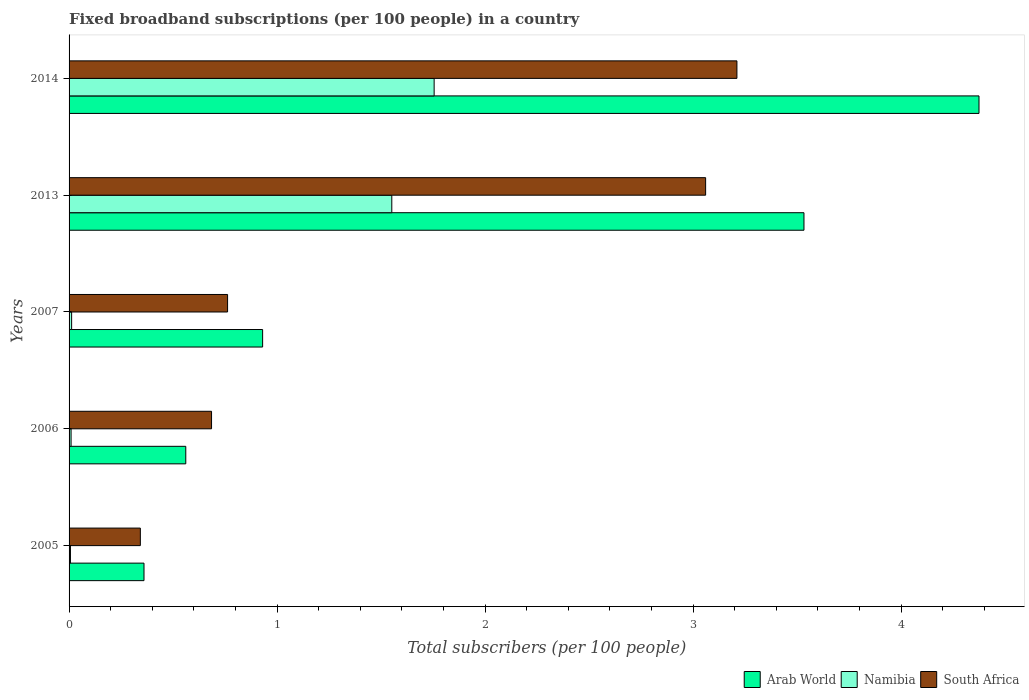How many groups of bars are there?
Offer a terse response. 5. How many bars are there on the 5th tick from the top?
Keep it short and to the point. 3. What is the number of broadband subscriptions in South Africa in 2005?
Your response must be concise. 0.34. Across all years, what is the maximum number of broadband subscriptions in Arab World?
Keep it short and to the point. 4.37. Across all years, what is the minimum number of broadband subscriptions in South Africa?
Offer a terse response. 0.34. In which year was the number of broadband subscriptions in Namibia maximum?
Provide a succinct answer. 2014. In which year was the number of broadband subscriptions in Arab World minimum?
Make the answer very short. 2005. What is the total number of broadband subscriptions in Namibia in the graph?
Offer a very short reply. 3.34. What is the difference between the number of broadband subscriptions in Namibia in 2005 and that in 2007?
Give a very brief answer. -0.01. What is the difference between the number of broadband subscriptions in Namibia in 2006 and the number of broadband subscriptions in South Africa in 2013?
Provide a succinct answer. -3.05. What is the average number of broadband subscriptions in South Africa per year?
Your answer should be compact. 1.61. In the year 2005, what is the difference between the number of broadband subscriptions in Namibia and number of broadband subscriptions in South Africa?
Keep it short and to the point. -0.34. What is the ratio of the number of broadband subscriptions in South Africa in 2013 to that in 2014?
Keep it short and to the point. 0.95. What is the difference between the highest and the second highest number of broadband subscriptions in South Africa?
Offer a terse response. 0.15. What is the difference between the highest and the lowest number of broadband subscriptions in Arab World?
Provide a short and direct response. 4.01. In how many years, is the number of broadband subscriptions in Namibia greater than the average number of broadband subscriptions in Namibia taken over all years?
Offer a very short reply. 2. What does the 3rd bar from the top in 2006 represents?
Your response must be concise. Arab World. What does the 1st bar from the bottom in 2006 represents?
Keep it short and to the point. Arab World. Is it the case that in every year, the sum of the number of broadband subscriptions in Arab World and number of broadband subscriptions in South Africa is greater than the number of broadband subscriptions in Namibia?
Provide a succinct answer. Yes. How many bars are there?
Keep it short and to the point. 15. Are all the bars in the graph horizontal?
Your answer should be compact. Yes. How many years are there in the graph?
Offer a very short reply. 5. Are the values on the major ticks of X-axis written in scientific E-notation?
Your answer should be very brief. No. Does the graph contain any zero values?
Make the answer very short. No. Does the graph contain grids?
Give a very brief answer. No. Where does the legend appear in the graph?
Your answer should be compact. Bottom right. How are the legend labels stacked?
Your answer should be compact. Horizontal. What is the title of the graph?
Your answer should be compact. Fixed broadband subscriptions (per 100 people) in a country. What is the label or title of the X-axis?
Your answer should be very brief. Total subscribers (per 100 people). What is the Total subscribers (per 100 people) in Arab World in 2005?
Offer a very short reply. 0.36. What is the Total subscribers (per 100 people) of Namibia in 2005?
Offer a very short reply. 0.01. What is the Total subscribers (per 100 people) in South Africa in 2005?
Keep it short and to the point. 0.34. What is the Total subscribers (per 100 people) in Arab World in 2006?
Provide a short and direct response. 0.56. What is the Total subscribers (per 100 people) in Namibia in 2006?
Offer a very short reply. 0.01. What is the Total subscribers (per 100 people) in South Africa in 2006?
Keep it short and to the point. 0.69. What is the Total subscribers (per 100 people) in Arab World in 2007?
Your response must be concise. 0.93. What is the Total subscribers (per 100 people) in Namibia in 2007?
Your response must be concise. 0.01. What is the Total subscribers (per 100 people) in South Africa in 2007?
Provide a short and direct response. 0.76. What is the Total subscribers (per 100 people) of Arab World in 2013?
Give a very brief answer. 3.53. What is the Total subscribers (per 100 people) of Namibia in 2013?
Offer a very short reply. 1.55. What is the Total subscribers (per 100 people) of South Africa in 2013?
Ensure brevity in your answer.  3.06. What is the Total subscribers (per 100 people) of Arab World in 2014?
Your answer should be very brief. 4.37. What is the Total subscribers (per 100 people) of Namibia in 2014?
Your answer should be compact. 1.76. What is the Total subscribers (per 100 people) in South Africa in 2014?
Give a very brief answer. 3.21. Across all years, what is the maximum Total subscribers (per 100 people) of Arab World?
Provide a short and direct response. 4.37. Across all years, what is the maximum Total subscribers (per 100 people) of Namibia?
Your answer should be very brief. 1.76. Across all years, what is the maximum Total subscribers (per 100 people) in South Africa?
Provide a succinct answer. 3.21. Across all years, what is the minimum Total subscribers (per 100 people) of Arab World?
Offer a terse response. 0.36. Across all years, what is the minimum Total subscribers (per 100 people) of Namibia?
Provide a succinct answer. 0.01. Across all years, what is the minimum Total subscribers (per 100 people) of South Africa?
Offer a very short reply. 0.34. What is the total Total subscribers (per 100 people) in Arab World in the graph?
Offer a very short reply. 9.76. What is the total Total subscribers (per 100 people) in Namibia in the graph?
Provide a short and direct response. 3.34. What is the total Total subscribers (per 100 people) of South Africa in the graph?
Ensure brevity in your answer.  8.06. What is the difference between the Total subscribers (per 100 people) of Arab World in 2005 and that in 2006?
Make the answer very short. -0.2. What is the difference between the Total subscribers (per 100 people) of Namibia in 2005 and that in 2006?
Ensure brevity in your answer.  -0. What is the difference between the Total subscribers (per 100 people) of South Africa in 2005 and that in 2006?
Provide a succinct answer. -0.34. What is the difference between the Total subscribers (per 100 people) in Arab World in 2005 and that in 2007?
Your response must be concise. -0.57. What is the difference between the Total subscribers (per 100 people) in Namibia in 2005 and that in 2007?
Your answer should be compact. -0.01. What is the difference between the Total subscribers (per 100 people) of South Africa in 2005 and that in 2007?
Make the answer very short. -0.42. What is the difference between the Total subscribers (per 100 people) of Arab World in 2005 and that in 2013?
Your answer should be compact. -3.17. What is the difference between the Total subscribers (per 100 people) of Namibia in 2005 and that in 2013?
Offer a very short reply. -1.55. What is the difference between the Total subscribers (per 100 people) of South Africa in 2005 and that in 2013?
Your answer should be compact. -2.72. What is the difference between the Total subscribers (per 100 people) in Arab World in 2005 and that in 2014?
Ensure brevity in your answer.  -4.01. What is the difference between the Total subscribers (per 100 people) of Namibia in 2005 and that in 2014?
Offer a terse response. -1.75. What is the difference between the Total subscribers (per 100 people) of South Africa in 2005 and that in 2014?
Your answer should be very brief. -2.87. What is the difference between the Total subscribers (per 100 people) in Arab World in 2006 and that in 2007?
Keep it short and to the point. -0.37. What is the difference between the Total subscribers (per 100 people) of Namibia in 2006 and that in 2007?
Your response must be concise. -0. What is the difference between the Total subscribers (per 100 people) in South Africa in 2006 and that in 2007?
Make the answer very short. -0.08. What is the difference between the Total subscribers (per 100 people) of Arab World in 2006 and that in 2013?
Offer a terse response. -2.97. What is the difference between the Total subscribers (per 100 people) of Namibia in 2006 and that in 2013?
Make the answer very short. -1.54. What is the difference between the Total subscribers (per 100 people) in South Africa in 2006 and that in 2013?
Offer a terse response. -2.38. What is the difference between the Total subscribers (per 100 people) in Arab World in 2006 and that in 2014?
Your response must be concise. -3.81. What is the difference between the Total subscribers (per 100 people) in Namibia in 2006 and that in 2014?
Provide a succinct answer. -1.75. What is the difference between the Total subscribers (per 100 people) of South Africa in 2006 and that in 2014?
Your answer should be compact. -2.53. What is the difference between the Total subscribers (per 100 people) in Arab World in 2007 and that in 2013?
Ensure brevity in your answer.  -2.6. What is the difference between the Total subscribers (per 100 people) of Namibia in 2007 and that in 2013?
Ensure brevity in your answer.  -1.54. What is the difference between the Total subscribers (per 100 people) in South Africa in 2007 and that in 2013?
Ensure brevity in your answer.  -2.3. What is the difference between the Total subscribers (per 100 people) in Arab World in 2007 and that in 2014?
Offer a terse response. -3.44. What is the difference between the Total subscribers (per 100 people) of Namibia in 2007 and that in 2014?
Ensure brevity in your answer.  -1.74. What is the difference between the Total subscribers (per 100 people) of South Africa in 2007 and that in 2014?
Your response must be concise. -2.45. What is the difference between the Total subscribers (per 100 people) in Arab World in 2013 and that in 2014?
Your answer should be very brief. -0.84. What is the difference between the Total subscribers (per 100 people) of Namibia in 2013 and that in 2014?
Your answer should be very brief. -0.2. What is the difference between the Total subscribers (per 100 people) of South Africa in 2013 and that in 2014?
Offer a very short reply. -0.15. What is the difference between the Total subscribers (per 100 people) of Arab World in 2005 and the Total subscribers (per 100 people) of Namibia in 2006?
Provide a succinct answer. 0.35. What is the difference between the Total subscribers (per 100 people) in Arab World in 2005 and the Total subscribers (per 100 people) in South Africa in 2006?
Keep it short and to the point. -0.32. What is the difference between the Total subscribers (per 100 people) of Namibia in 2005 and the Total subscribers (per 100 people) of South Africa in 2006?
Keep it short and to the point. -0.68. What is the difference between the Total subscribers (per 100 people) in Arab World in 2005 and the Total subscribers (per 100 people) in Namibia in 2007?
Offer a terse response. 0.35. What is the difference between the Total subscribers (per 100 people) of Arab World in 2005 and the Total subscribers (per 100 people) of South Africa in 2007?
Your answer should be very brief. -0.4. What is the difference between the Total subscribers (per 100 people) in Namibia in 2005 and the Total subscribers (per 100 people) in South Africa in 2007?
Provide a short and direct response. -0.76. What is the difference between the Total subscribers (per 100 people) of Arab World in 2005 and the Total subscribers (per 100 people) of Namibia in 2013?
Ensure brevity in your answer.  -1.19. What is the difference between the Total subscribers (per 100 people) in Arab World in 2005 and the Total subscribers (per 100 people) in South Africa in 2013?
Keep it short and to the point. -2.7. What is the difference between the Total subscribers (per 100 people) in Namibia in 2005 and the Total subscribers (per 100 people) in South Africa in 2013?
Provide a succinct answer. -3.05. What is the difference between the Total subscribers (per 100 people) of Arab World in 2005 and the Total subscribers (per 100 people) of Namibia in 2014?
Offer a terse response. -1.39. What is the difference between the Total subscribers (per 100 people) in Arab World in 2005 and the Total subscribers (per 100 people) in South Africa in 2014?
Your answer should be compact. -2.85. What is the difference between the Total subscribers (per 100 people) in Namibia in 2005 and the Total subscribers (per 100 people) in South Africa in 2014?
Offer a very short reply. -3.2. What is the difference between the Total subscribers (per 100 people) of Arab World in 2006 and the Total subscribers (per 100 people) of Namibia in 2007?
Provide a succinct answer. 0.55. What is the difference between the Total subscribers (per 100 people) of Arab World in 2006 and the Total subscribers (per 100 people) of South Africa in 2007?
Your answer should be compact. -0.2. What is the difference between the Total subscribers (per 100 people) of Namibia in 2006 and the Total subscribers (per 100 people) of South Africa in 2007?
Provide a short and direct response. -0.75. What is the difference between the Total subscribers (per 100 people) in Arab World in 2006 and the Total subscribers (per 100 people) in Namibia in 2013?
Offer a very short reply. -0.99. What is the difference between the Total subscribers (per 100 people) of Arab World in 2006 and the Total subscribers (per 100 people) of South Africa in 2013?
Your answer should be compact. -2.5. What is the difference between the Total subscribers (per 100 people) in Namibia in 2006 and the Total subscribers (per 100 people) in South Africa in 2013?
Make the answer very short. -3.05. What is the difference between the Total subscribers (per 100 people) of Arab World in 2006 and the Total subscribers (per 100 people) of Namibia in 2014?
Your response must be concise. -1.19. What is the difference between the Total subscribers (per 100 people) in Arab World in 2006 and the Total subscribers (per 100 people) in South Africa in 2014?
Your answer should be very brief. -2.65. What is the difference between the Total subscribers (per 100 people) of Namibia in 2006 and the Total subscribers (per 100 people) of South Africa in 2014?
Keep it short and to the point. -3.2. What is the difference between the Total subscribers (per 100 people) of Arab World in 2007 and the Total subscribers (per 100 people) of Namibia in 2013?
Offer a very short reply. -0.62. What is the difference between the Total subscribers (per 100 people) in Arab World in 2007 and the Total subscribers (per 100 people) in South Africa in 2013?
Ensure brevity in your answer.  -2.13. What is the difference between the Total subscribers (per 100 people) of Namibia in 2007 and the Total subscribers (per 100 people) of South Africa in 2013?
Ensure brevity in your answer.  -3.05. What is the difference between the Total subscribers (per 100 people) of Arab World in 2007 and the Total subscribers (per 100 people) of Namibia in 2014?
Provide a succinct answer. -0.82. What is the difference between the Total subscribers (per 100 people) in Arab World in 2007 and the Total subscribers (per 100 people) in South Africa in 2014?
Your answer should be compact. -2.28. What is the difference between the Total subscribers (per 100 people) in Namibia in 2007 and the Total subscribers (per 100 people) in South Africa in 2014?
Your answer should be compact. -3.2. What is the difference between the Total subscribers (per 100 people) of Arab World in 2013 and the Total subscribers (per 100 people) of Namibia in 2014?
Make the answer very short. 1.78. What is the difference between the Total subscribers (per 100 people) in Arab World in 2013 and the Total subscribers (per 100 people) in South Africa in 2014?
Ensure brevity in your answer.  0.32. What is the difference between the Total subscribers (per 100 people) in Namibia in 2013 and the Total subscribers (per 100 people) in South Africa in 2014?
Provide a short and direct response. -1.66. What is the average Total subscribers (per 100 people) in Arab World per year?
Give a very brief answer. 1.95. What is the average Total subscribers (per 100 people) of Namibia per year?
Your response must be concise. 0.67. What is the average Total subscribers (per 100 people) in South Africa per year?
Give a very brief answer. 1.61. In the year 2005, what is the difference between the Total subscribers (per 100 people) of Arab World and Total subscribers (per 100 people) of Namibia?
Make the answer very short. 0.35. In the year 2005, what is the difference between the Total subscribers (per 100 people) of Arab World and Total subscribers (per 100 people) of South Africa?
Offer a terse response. 0.02. In the year 2005, what is the difference between the Total subscribers (per 100 people) of Namibia and Total subscribers (per 100 people) of South Africa?
Make the answer very short. -0.34. In the year 2006, what is the difference between the Total subscribers (per 100 people) of Arab World and Total subscribers (per 100 people) of Namibia?
Make the answer very short. 0.55. In the year 2006, what is the difference between the Total subscribers (per 100 people) in Arab World and Total subscribers (per 100 people) in South Africa?
Your answer should be very brief. -0.12. In the year 2006, what is the difference between the Total subscribers (per 100 people) of Namibia and Total subscribers (per 100 people) of South Africa?
Ensure brevity in your answer.  -0.68. In the year 2007, what is the difference between the Total subscribers (per 100 people) in Arab World and Total subscribers (per 100 people) in Namibia?
Offer a very short reply. 0.92. In the year 2007, what is the difference between the Total subscribers (per 100 people) of Arab World and Total subscribers (per 100 people) of South Africa?
Keep it short and to the point. 0.17. In the year 2007, what is the difference between the Total subscribers (per 100 people) in Namibia and Total subscribers (per 100 people) in South Africa?
Your answer should be very brief. -0.75. In the year 2013, what is the difference between the Total subscribers (per 100 people) of Arab World and Total subscribers (per 100 people) of Namibia?
Give a very brief answer. 1.98. In the year 2013, what is the difference between the Total subscribers (per 100 people) of Arab World and Total subscribers (per 100 people) of South Africa?
Keep it short and to the point. 0.47. In the year 2013, what is the difference between the Total subscribers (per 100 people) of Namibia and Total subscribers (per 100 people) of South Africa?
Offer a terse response. -1.51. In the year 2014, what is the difference between the Total subscribers (per 100 people) of Arab World and Total subscribers (per 100 people) of Namibia?
Provide a short and direct response. 2.62. In the year 2014, what is the difference between the Total subscribers (per 100 people) in Arab World and Total subscribers (per 100 people) in South Africa?
Ensure brevity in your answer.  1.16. In the year 2014, what is the difference between the Total subscribers (per 100 people) in Namibia and Total subscribers (per 100 people) in South Africa?
Your answer should be compact. -1.46. What is the ratio of the Total subscribers (per 100 people) in Arab World in 2005 to that in 2006?
Ensure brevity in your answer.  0.64. What is the ratio of the Total subscribers (per 100 people) in Namibia in 2005 to that in 2006?
Offer a terse response. 0.69. What is the ratio of the Total subscribers (per 100 people) in South Africa in 2005 to that in 2006?
Offer a terse response. 0.5. What is the ratio of the Total subscribers (per 100 people) of Arab World in 2005 to that in 2007?
Give a very brief answer. 0.39. What is the ratio of the Total subscribers (per 100 people) in Namibia in 2005 to that in 2007?
Your response must be concise. 0.54. What is the ratio of the Total subscribers (per 100 people) of South Africa in 2005 to that in 2007?
Offer a very short reply. 0.45. What is the ratio of the Total subscribers (per 100 people) of Arab World in 2005 to that in 2013?
Give a very brief answer. 0.1. What is the ratio of the Total subscribers (per 100 people) in Namibia in 2005 to that in 2013?
Give a very brief answer. 0. What is the ratio of the Total subscribers (per 100 people) of South Africa in 2005 to that in 2013?
Give a very brief answer. 0.11. What is the ratio of the Total subscribers (per 100 people) of Arab World in 2005 to that in 2014?
Make the answer very short. 0.08. What is the ratio of the Total subscribers (per 100 people) in Namibia in 2005 to that in 2014?
Keep it short and to the point. 0. What is the ratio of the Total subscribers (per 100 people) of South Africa in 2005 to that in 2014?
Give a very brief answer. 0.11. What is the ratio of the Total subscribers (per 100 people) of Arab World in 2006 to that in 2007?
Your answer should be compact. 0.6. What is the ratio of the Total subscribers (per 100 people) of Namibia in 2006 to that in 2007?
Offer a very short reply. 0.78. What is the ratio of the Total subscribers (per 100 people) of South Africa in 2006 to that in 2007?
Offer a terse response. 0.9. What is the ratio of the Total subscribers (per 100 people) in Arab World in 2006 to that in 2013?
Provide a succinct answer. 0.16. What is the ratio of the Total subscribers (per 100 people) of Namibia in 2006 to that in 2013?
Keep it short and to the point. 0.01. What is the ratio of the Total subscribers (per 100 people) of South Africa in 2006 to that in 2013?
Keep it short and to the point. 0.22. What is the ratio of the Total subscribers (per 100 people) of Arab World in 2006 to that in 2014?
Offer a very short reply. 0.13. What is the ratio of the Total subscribers (per 100 people) in Namibia in 2006 to that in 2014?
Offer a very short reply. 0.01. What is the ratio of the Total subscribers (per 100 people) of South Africa in 2006 to that in 2014?
Keep it short and to the point. 0.21. What is the ratio of the Total subscribers (per 100 people) in Arab World in 2007 to that in 2013?
Ensure brevity in your answer.  0.26. What is the ratio of the Total subscribers (per 100 people) of Namibia in 2007 to that in 2013?
Give a very brief answer. 0.01. What is the ratio of the Total subscribers (per 100 people) in South Africa in 2007 to that in 2013?
Provide a short and direct response. 0.25. What is the ratio of the Total subscribers (per 100 people) of Arab World in 2007 to that in 2014?
Provide a short and direct response. 0.21. What is the ratio of the Total subscribers (per 100 people) in Namibia in 2007 to that in 2014?
Give a very brief answer. 0.01. What is the ratio of the Total subscribers (per 100 people) in South Africa in 2007 to that in 2014?
Offer a very short reply. 0.24. What is the ratio of the Total subscribers (per 100 people) of Arab World in 2013 to that in 2014?
Your answer should be compact. 0.81. What is the ratio of the Total subscribers (per 100 people) in Namibia in 2013 to that in 2014?
Your response must be concise. 0.88. What is the ratio of the Total subscribers (per 100 people) of South Africa in 2013 to that in 2014?
Your response must be concise. 0.95. What is the difference between the highest and the second highest Total subscribers (per 100 people) in Arab World?
Keep it short and to the point. 0.84. What is the difference between the highest and the second highest Total subscribers (per 100 people) of Namibia?
Keep it short and to the point. 0.2. What is the difference between the highest and the second highest Total subscribers (per 100 people) in South Africa?
Ensure brevity in your answer.  0.15. What is the difference between the highest and the lowest Total subscribers (per 100 people) in Arab World?
Provide a succinct answer. 4.01. What is the difference between the highest and the lowest Total subscribers (per 100 people) in Namibia?
Ensure brevity in your answer.  1.75. What is the difference between the highest and the lowest Total subscribers (per 100 people) in South Africa?
Provide a short and direct response. 2.87. 